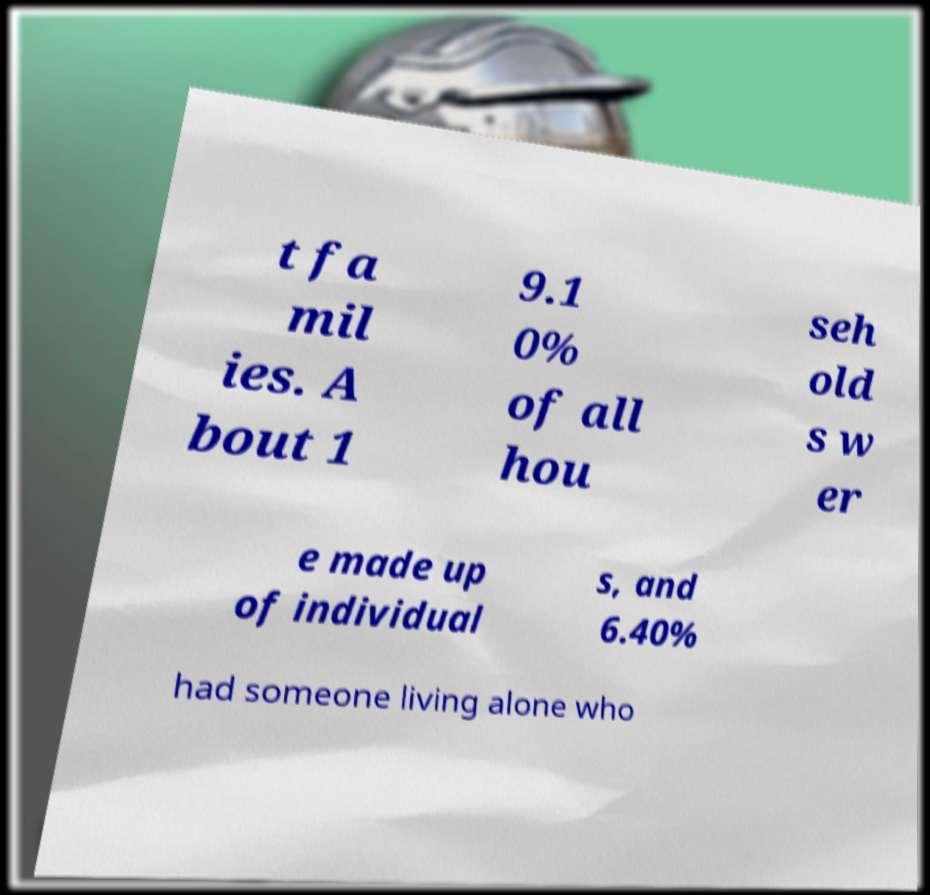Could you assist in decoding the text presented in this image and type it out clearly? t fa mil ies. A bout 1 9.1 0% of all hou seh old s w er e made up of individual s, and 6.40% had someone living alone who 